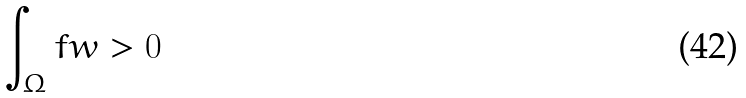Convert formula to latex. <formula><loc_0><loc_0><loc_500><loc_500>\int _ { \Omega } f w > 0</formula> 